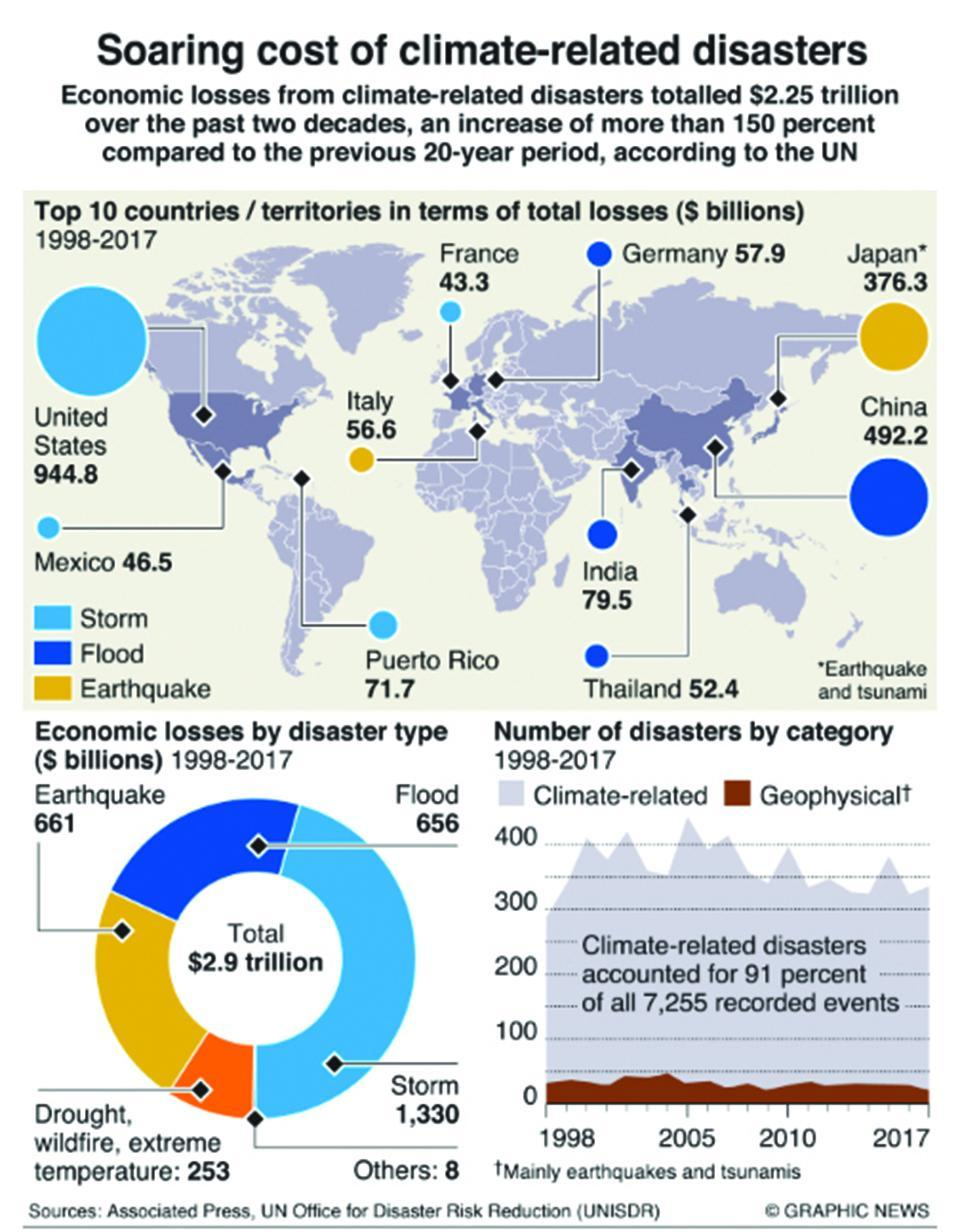Which country has suffered the highest amount of economic loss from earth quakes during 1998-2017?
Answer the question with a short phrase. Japan What is the total economic loss (in $ billions) caused by the floods during 1998-2017? 656 What is the economic loss (in $ billions) caused by storms in France during 1998-2017? 43.3 Which country has suffered the highest amount of economic loss from storms during 1998-2017? United States What is the total economic loss (in $ billions) caused by the storms during 1998-2017? 1,330 Which country has suffered the highest amount of economic loss from floods during 1998-2017? China What is the economic loss (in $ billions) caused by earthquakes in Italy during 1998-2017? 56.6 Which country has suffered the least amount of economic loss from floods during 1998-2017? Thailand Which country has suffered the least amount of economic loss from earth quakes during 1998-2017? Italy What is the economic loss (in $ billions) caused by earthquakes in India during 1998-2017? 79.5 